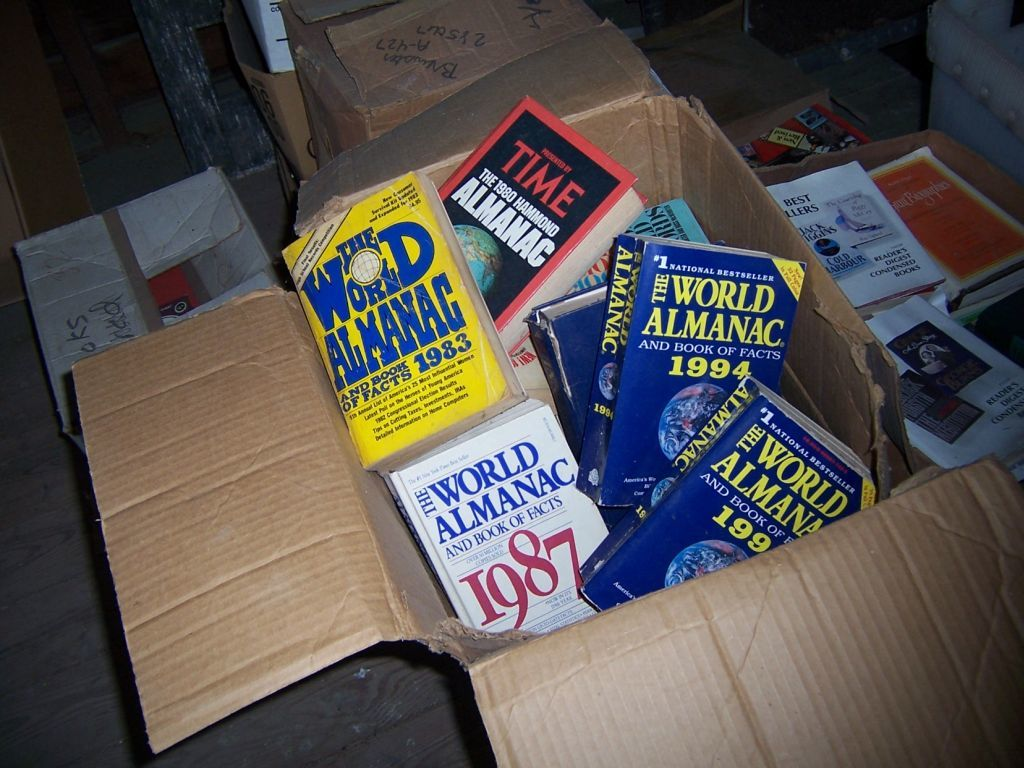What can these specific almanac editions tell us about the late 20th century? These almanacs, with editions spanning from the early 1980s to mid-1990s, likely contain a wealth of information on historical events, scientific discoveries, and notable figures of that period, reflecting the shifts in political, technological, and cultural landscapes. Can you infer why someone might keep these old editions? Someone might keep these old editions for their historical value, nostalgia, or for research purposes, as they provide a snapshot of world knowledge and societal priorities at the time of their publication. 